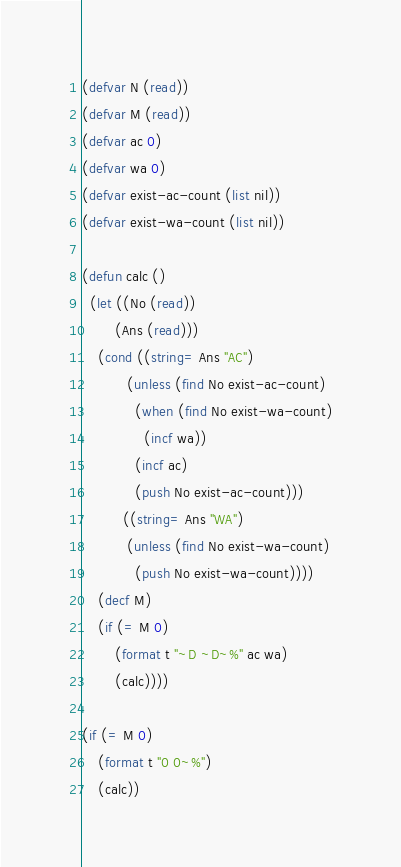Convert code to text. <code><loc_0><loc_0><loc_500><loc_500><_Lisp_>(defvar N (read))
(defvar M (read))
(defvar ac 0)
(defvar wa 0)
(defvar exist-ac-count (list nil))
(defvar exist-wa-count (list nil))

(defun calc ()
  (let ((No (read))
        (Ans (read)))
    (cond ((string= Ans "AC")
           (unless (find No exist-ac-count)
             (when (find No exist-wa-count)
               (incf wa))
             (incf ac)
             (push No exist-ac-count)))
          ((string= Ans "WA")
           (unless (find No exist-wa-count)
             (push No exist-wa-count))))
    (decf M)
    (if (= M 0)
        (format t "~D ~D~%" ac wa)
        (calc))))

(if (= M 0)
    (format t "0 0~%")
    (calc))
</code> 